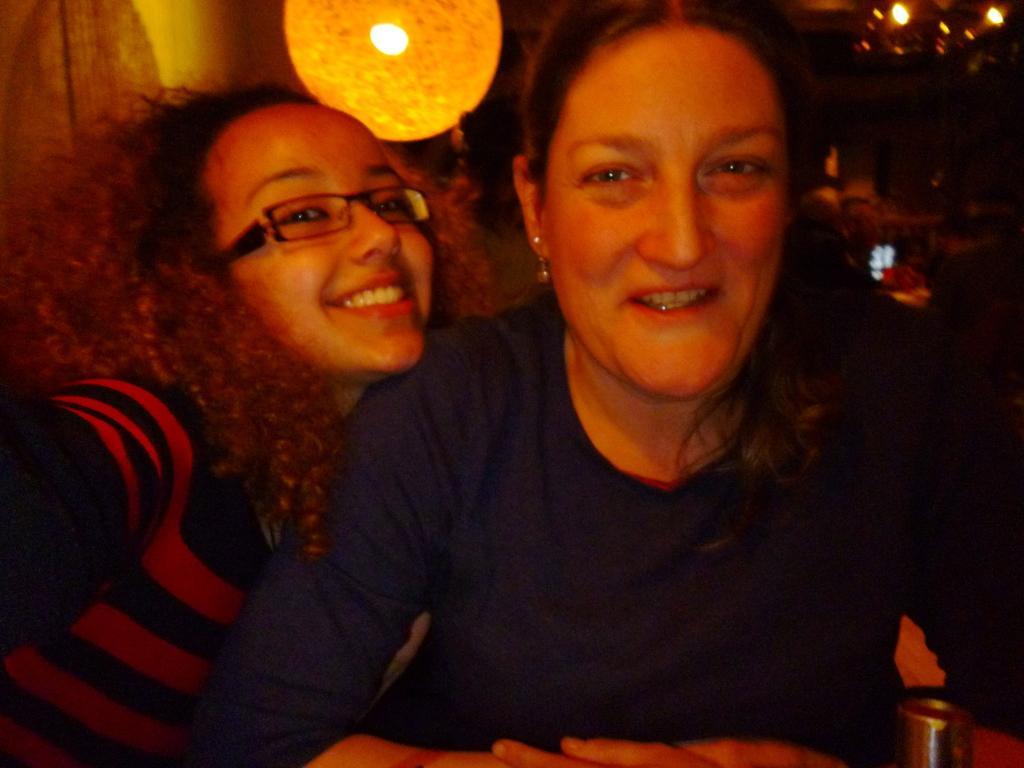Can you describe this image briefly? In this image I can see two people smiling and wearing different color dresses. Back I can see few lights and a dark background. 